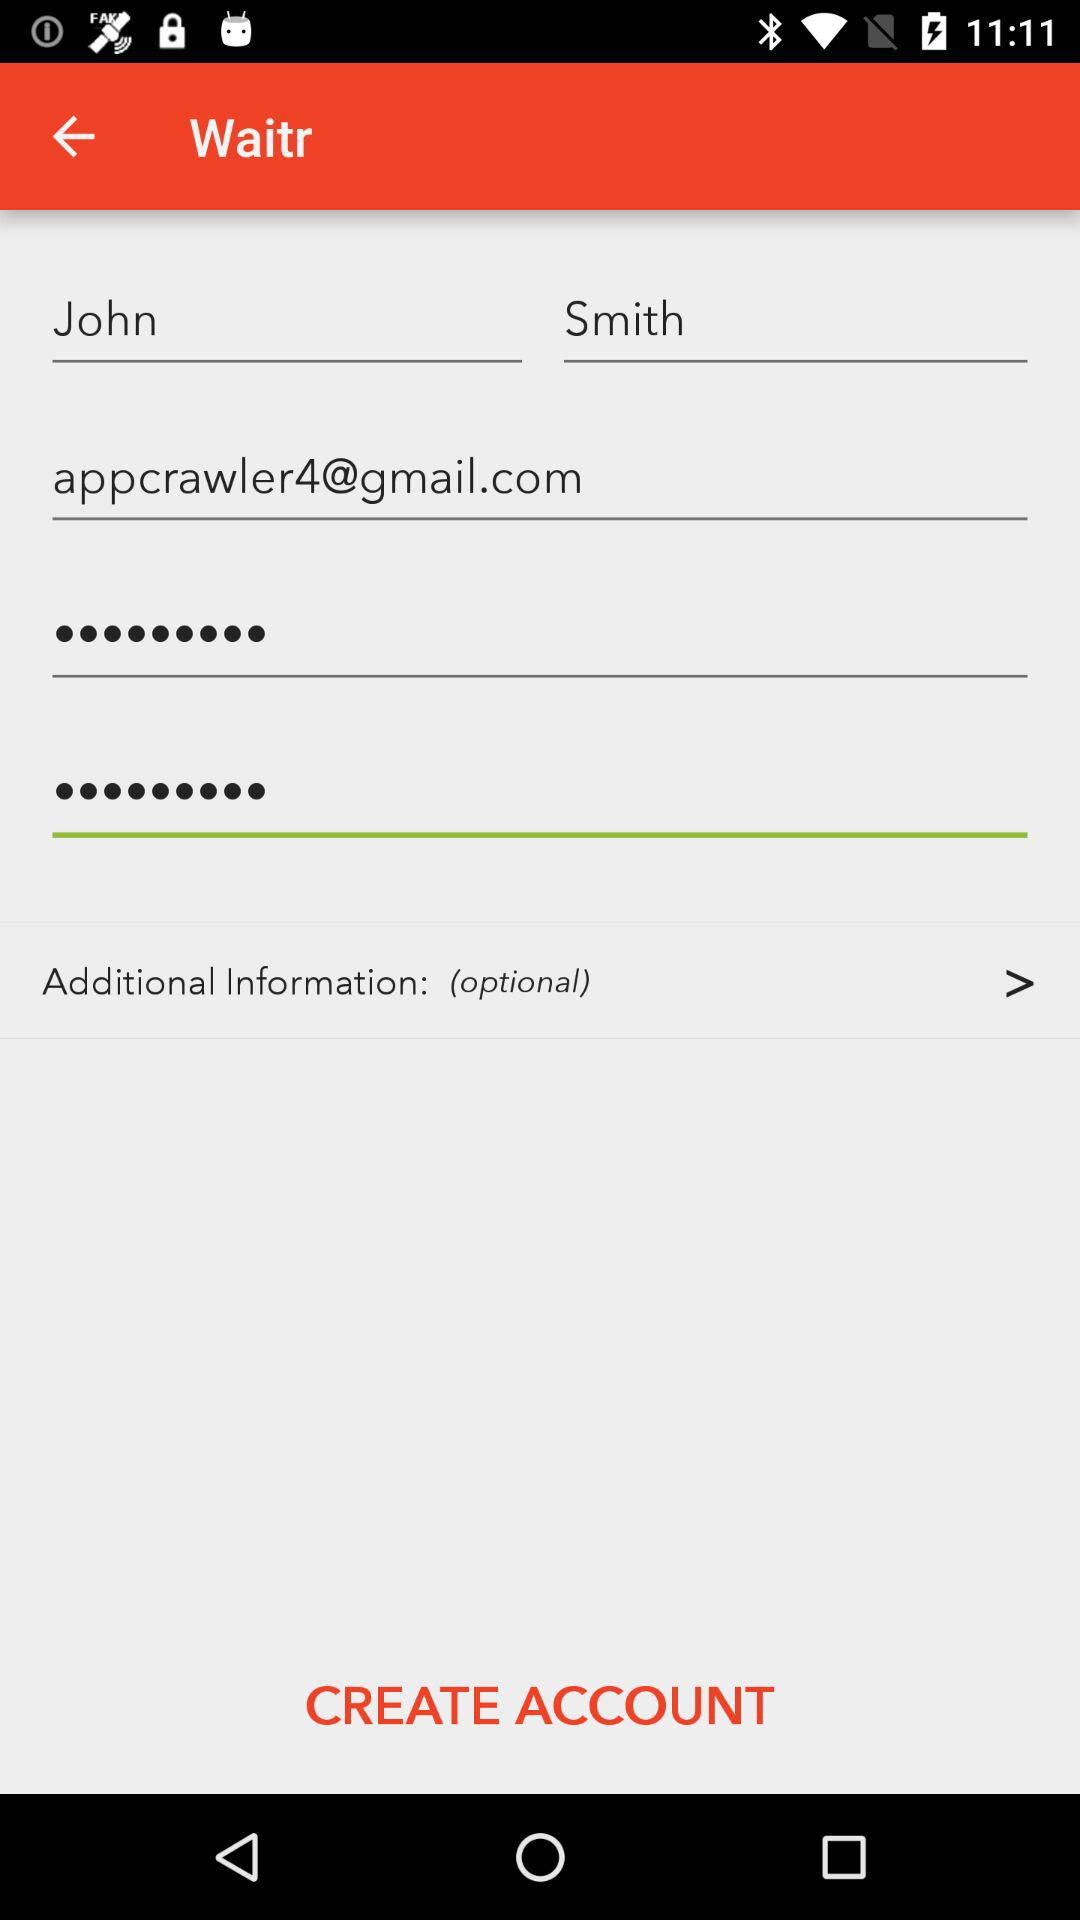What is the name? The name is John Smith. 